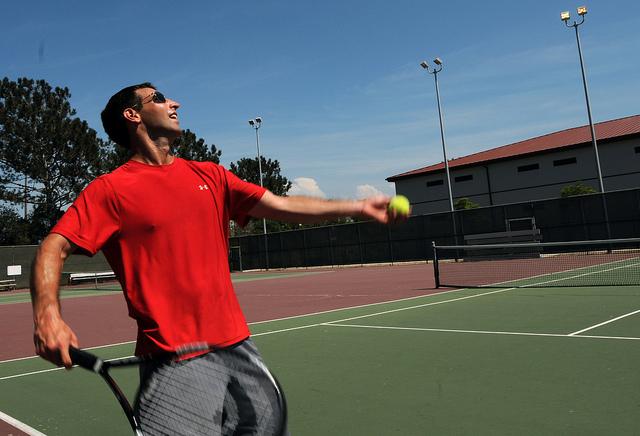What is the person on the right doing with the ball?
Keep it brief. Serving. Is the man having fun?
Give a very brief answer. Yes. Is the guy wearing a hat?
Concise answer only. No. What color is his shirt?
Short answer required. Red. Is this man a professional tennis player?
Give a very brief answer. No. Are there people in the background?
Give a very brief answer. No. What color is the court?
Concise answer only. Green. Who is holding the racket?
Give a very brief answer. Man. Is he serving or returning the ball?
Keep it brief. Serving. Is this image shot in one-point perspective?
Be succinct. Yes. Is he holding the racket with two hands?
Quick response, please. No. Is the man really playing tennis?
Answer briefly. Yes. Is he standing outside the playing area?
Answer briefly. Yes. Is it evening?
Short answer required. No. Is the man a tennis professional?
Short answer required. No. Is it cloudy?
Concise answer only. No. Is the man a professional tennis player?
Concise answer only. No. Is the man tan?
Answer briefly. Yes. What is the man dressed in?
Keep it brief. T-shirt. Is he holding the racquet correctly for a backhand?
Answer briefly. No. What is the guy doing?
Short answer required. Playing tennis. Is the man skateboarding?
Give a very brief answer. No. What game is the man playing?
Quick response, please. Tennis. What color is the man's shirt?
Write a very short answer. Red. Where is the ball?
Short answer required. Hand. How many tennis balls is he holding?
Answer briefly. 1. Is he serving?
Quick response, please. Yes. Would the person in the red top have experience equality if they had lived 100 years ago?
Concise answer only. Yes. Is the player wearing sunglasses?
Concise answer only. Yes. What color is the man's outfit?
Concise answer only. Red and gray. Is the man wearing a shirt?
Short answer required. Yes. What color is this person's shirt?
Give a very brief answer. Red. How is the building designed?
Concise answer only. Square. What substance is the tennis court?
Answer briefly. Grass. What year was this taken in?
Quick response, please. 2015. Is the ball coming toward the man?
Short answer required. No. What is the job of the person in the red top?
Answer briefly. Tennis player. What color are the fence post?
Give a very brief answer. Black. 